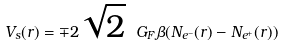<formula> <loc_0><loc_0><loc_500><loc_500>V _ { s } ( r ) = \mp 2 \sqrt { 2 } \ G _ { F } \beta ( N _ { e ^ { - } } ( r ) - N _ { e ^ { + } } ( r ) )</formula> 